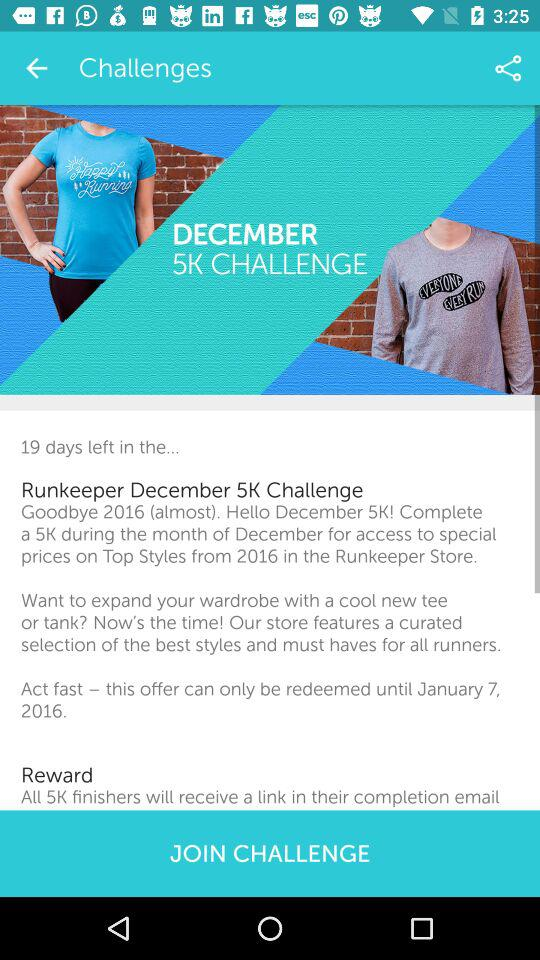When can I redeem the offer? You can redeem the offer until January 7, 2016. 